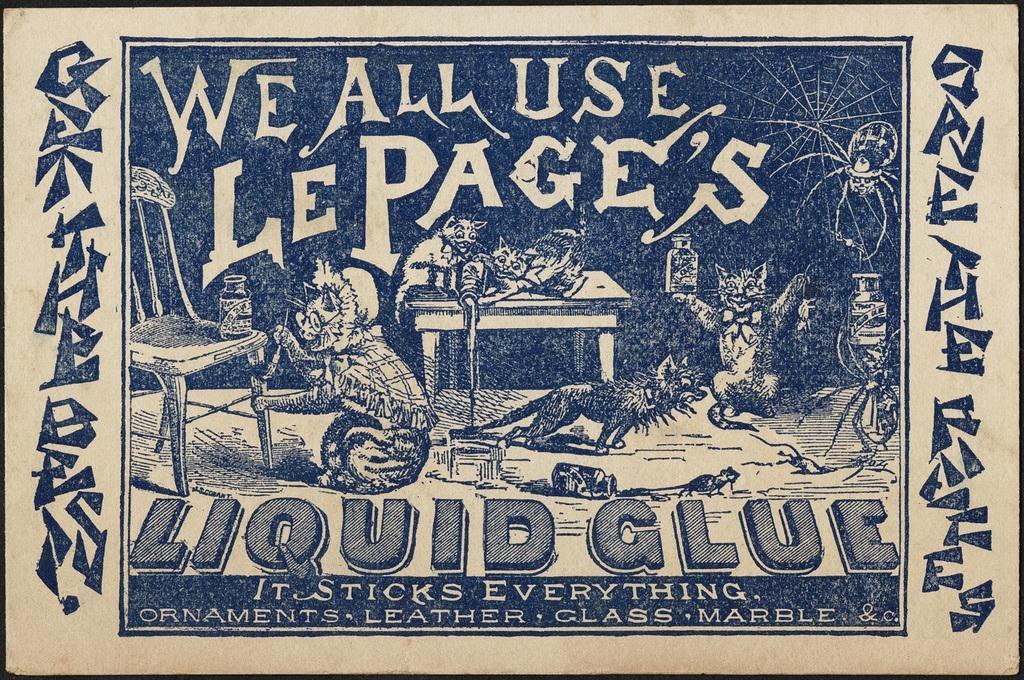Describe this image in one or two sentences. In the foreground of this poster, there is text and images of cats, chair, bottle, rat, spider and few objects. 